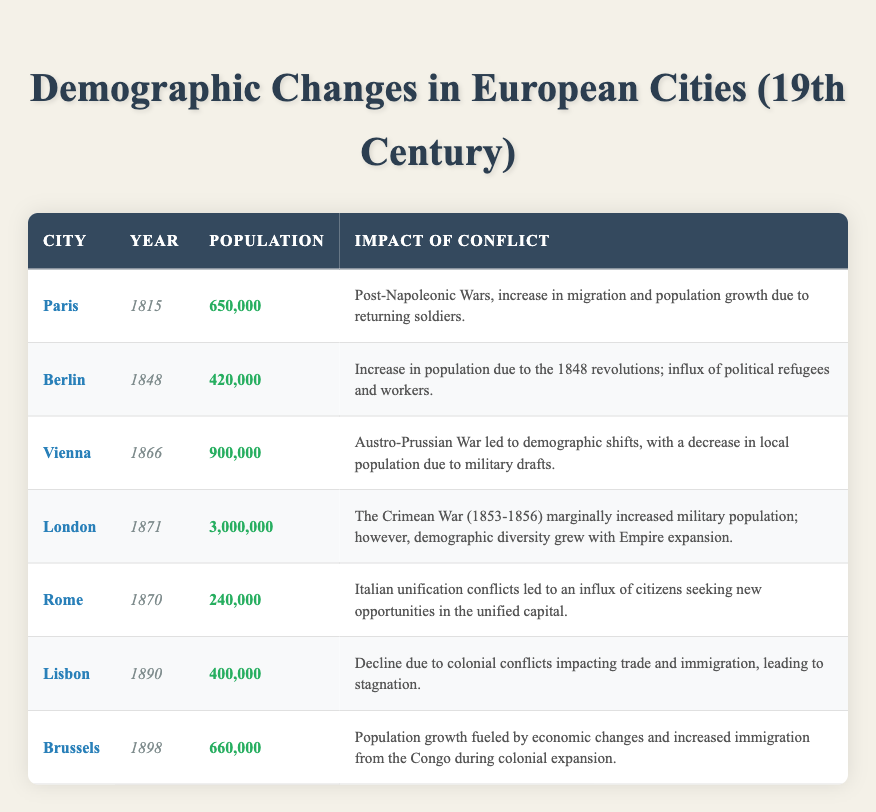What was the population of Vienna in 1866? The table states that the population of Vienna in 1866 was 900,000.
Answer: 900,000 Which city had the highest population in 1871? According to the table, London had the highest population at 3,000,000 in 1871.
Answer: London Did the Austro-Prussian War in 1866 lead to a population increase in Vienna? The impact of conflict section for Vienna in 1866 mentions a decrease in local population due to military drafts, indicating a population decrease rather than an increase.
Answer: No Calculate the total population of Paris in 1815 and Berlin in 1848. From the table, the populations are 650,000 in Paris and 420,000 in Berlin. Summing them gives 650,000 + 420,000 = 1,070,000.
Answer: 1,070,000 Was there an influx of immigration in Brussels by 1898? The data indicates that in 1898, Brussels experienced population growth fueled by immigration from the Congo, suggesting a significant influx.
Answer: Yes What were the reasons for the population decline in Lisbon by 1890? The entry for Lisbon mentions a decline due to colonial conflicts impacting trade and immigration, leading to stagnation.
Answer: Colonial conflicts and stagnation Which two cities reported population impacts due to conflicts in 1870? Looking at the table, Rome in 1870 experienced impacts due to Italian unification conflicts, and London in 1871 experienced demographic changes from the Crimean War.
Answer: Rome and London What was the population of the cities in the table from 1815 to 1898? The populations of the cities listed in the table for their respective years are: Paris (650,000), Berlin (420,000), Vienna (900,000), London (3,000,000), Rome (240,000), Lisbon (400,000), and Brussels (660,000). The populations varied significantly across the years, with London having the highest population in 1871.
Answer: Varied significantly; London had 3,000,000 How did the population of Berlin change from 1848 to 1866? In 1848, Berlin had a population of 420,000, and by 1866, there is no direct reference to the population in Berlin for that year in the data provided; hence, no comparative analysis can be made. The question illustrates the lack of data for 1866 for Berlin.
Answer: Cannot be determined 